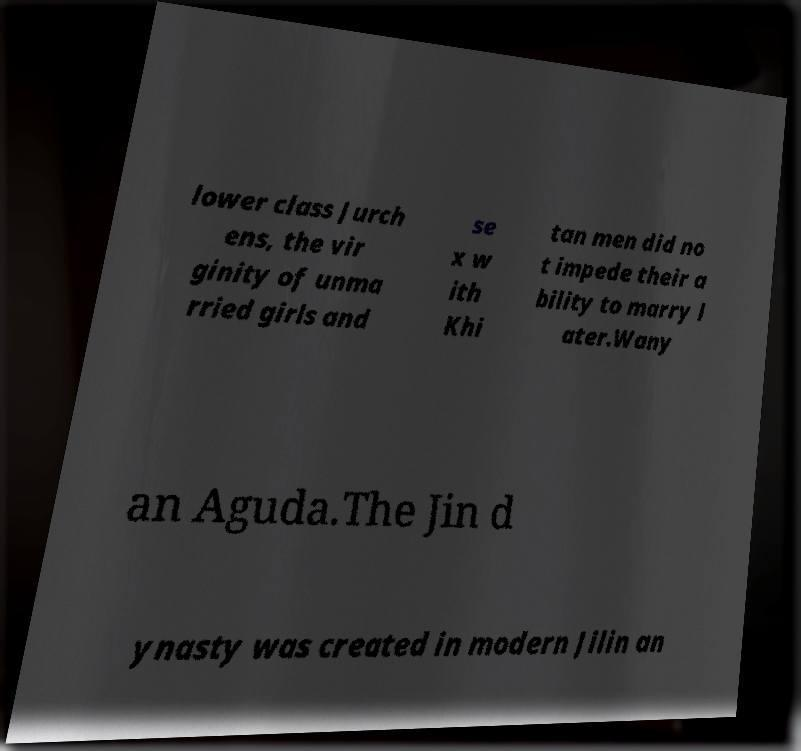Please read and relay the text visible in this image. What does it say? lower class Jurch ens, the vir ginity of unma rried girls and se x w ith Khi tan men did no t impede their a bility to marry l ater.Wany an Aguda.The Jin d ynasty was created in modern Jilin an 